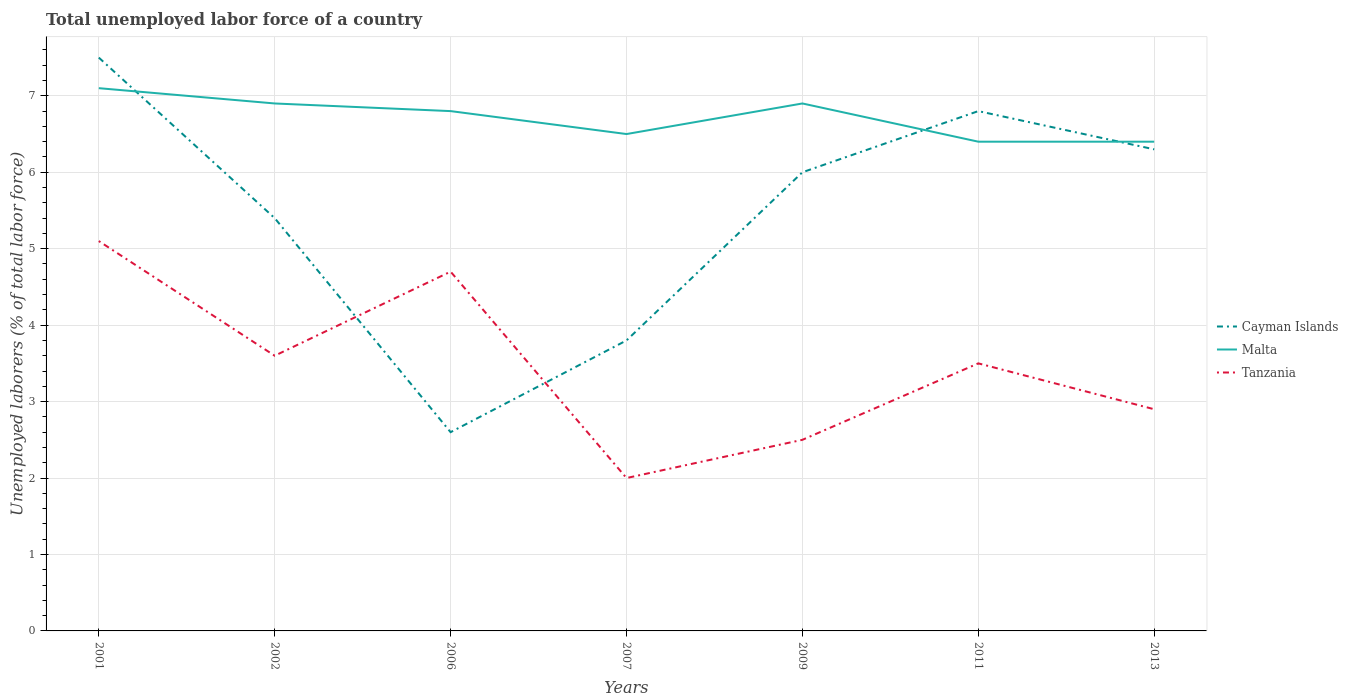Is the number of lines equal to the number of legend labels?
Provide a succinct answer. Yes. Across all years, what is the maximum total unemployed labor force in Malta?
Your response must be concise. 6.4. In which year was the total unemployed labor force in Cayman Islands maximum?
Offer a terse response. 2006. What is the total total unemployed labor force in Malta in the graph?
Your response must be concise. -0.4. What is the difference between the highest and the second highest total unemployed labor force in Tanzania?
Your answer should be compact. 3.1. What is the difference between the highest and the lowest total unemployed labor force in Tanzania?
Keep it short and to the point. 4. Is the total unemployed labor force in Malta strictly greater than the total unemployed labor force in Tanzania over the years?
Make the answer very short. No. What is the difference between two consecutive major ticks on the Y-axis?
Give a very brief answer. 1. Are the values on the major ticks of Y-axis written in scientific E-notation?
Give a very brief answer. No. Does the graph contain any zero values?
Your answer should be very brief. No. Does the graph contain grids?
Make the answer very short. Yes. Where does the legend appear in the graph?
Offer a very short reply. Center right. How are the legend labels stacked?
Your response must be concise. Vertical. What is the title of the graph?
Your response must be concise. Total unemployed labor force of a country. Does "Cabo Verde" appear as one of the legend labels in the graph?
Your answer should be very brief. No. What is the label or title of the Y-axis?
Your response must be concise. Unemployed laborers (% of total labor force). What is the Unemployed laborers (% of total labor force) in Malta in 2001?
Your answer should be very brief. 7.1. What is the Unemployed laborers (% of total labor force) in Tanzania in 2001?
Provide a succinct answer. 5.1. What is the Unemployed laborers (% of total labor force) of Cayman Islands in 2002?
Keep it short and to the point. 5.4. What is the Unemployed laborers (% of total labor force) of Malta in 2002?
Your answer should be very brief. 6.9. What is the Unemployed laborers (% of total labor force) in Tanzania in 2002?
Give a very brief answer. 3.6. What is the Unemployed laborers (% of total labor force) of Cayman Islands in 2006?
Provide a succinct answer. 2.6. What is the Unemployed laborers (% of total labor force) in Malta in 2006?
Offer a terse response. 6.8. What is the Unemployed laborers (% of total labor force) of Tanzania in 2006?
Offer a very short reply. 4.7. What is the Unemployed laborers (% of total labor force) in Cayman Islands in 2007?
Make the answer very short. 3.8. What is the Unemployed laborers (% of total labor force) in Tanzania in 2007?
Your answer should be very brief. 2. What is the Unemployed laborers (% of total labor force) in Malta in 2009?
Give a very brief answer. 6.9. What is the Unemployed laborers (% of total labor force) of Tanzania in 2009?
Keep it short and to the point. 2.5. What is the Unemployed laborers (% of total labor force) in Cayman Islands in 2011?
Your answer should be very brief. 6.8. What is the Unemployed laborers (% of total labor force) in Malta in 2011?
Offer a very short reply. 6.4. What is the Unemployed laborers (% of total labor force) of Tanzania in 2011?
Offer a terse response. 3.5. What is the Unemployed laborers (% of total labor force) of Cayman Islands in 2013?
Your answer should be compact. 6.3. What is the Unemployed laborers (% of total labor force) of Malta in 2013?
Your response must be concise. 6.4. What is the Unemployed laborers (% of total labor force) of Tanzania in 2013?
Keep it short and to the point. 2.9. Across all years, what is the maximum Unemployed laborers (% of total labor force) of Cayman Islands?
Your answer should be compact. 7.5. Across all years, what is the maximum Unemployed laborers (% of total labor force) of Malta?
Ensure brevity in your answer.  7.1. Across all years, what is the maximum Unemployed laborers (% of total labor force) in Tanzania?
Offer a terse response. 5.1. Across all years, what is the minimum Unemployed laborers (% of total labor force) in Cayman Islands?
Your response must be concise. 2.6. Across all years, what is the minimum Unemployed laborers (% of total labor force) in Malta?
Make the answer very short. 6.4. What is the total Unemployed laborers (% of total labor force) of Cayman Islands in the graph?
Ensure brevity in your answer.  38.4. What is the total Unemployed laborers (% of total labor force) in Malta in the graph?
Provide a succinct answer. 47. What is the total Unemployed laborers (% of total labor force) in Tanzania in the graph?
Your answer should be compact. 24.3. What is the difference between the Unemployed laborers (% of total labor force) in Malta in 2001 and that in 2002?
Offer a very short reply. 0.2. What is the difference between the Unemployed laborers (% of total labor force) of Cayman Islands in 2001 and that in 2006?
Ensure brevity in your answer.  4.9. What is the difference between the Unemployed laborers (% of total labor force) of Malta in 2001 and that in 2006?
Make the answer very short. 0.3. What is the difference between the Unemployed laborers (% of total labor force) in Tanzania in 2001 and that in 2006?
Ensure brevity in your answer.  0.4. What is the difference between the Unemployed laborers (% of total labor force) of Cayman Islands in 2001 and that in 2007?
Ensure brevity in your answer.  3.7. What is the difference between the Unemployed laborers (% of total labor force) in Cayman Islands in 2001 and that in 2013?
Keep it short and to the point. 1.2. What is the difference between the Unemployed laborers (% of total labor force) in Cayman Islands in 2002 and that in 2007?
Provide a short and direct response. 1.6. What is the difference between the Unemployed laborers (% of total labor force) of Malta in 2002 and that in 2007?
Ensure brevity in your answer.  0.4. What is the difference between the Unemployed laborers (% of total labor force) in Malta in 2002 and that in 2009?
Offer a terse response. 0. What is the difference between the Unemployed laborers (% of total labor force) of Cayman Islands in 2002 and that in 2013?
Offer a very short reply. -0.9. What is the difference between the Unemployed laborers (% of total labor force) of Malta in 2002 and that in 2013?
Your answer should be very brief. 0.5. What is the difference between the Unemployed laborers (% of total labor force) in Tanzania in 2002 and that in 2013?
Make the answer very short. 0.7. What is the difference between the Unemployed laborers (% of total labor force) in Cayman Islands in 2006 and that in 2007?
Provide a succinct answer. -1.2. What is the difference between the Unemployed laborers (% of total labor force) of Malta in 2006 and that in 2007?
Your response must be concise. 0.3. What is the difference between the Unemployed laborers (% of total labor force) in Cayman Islands in 2006 and that in 2009?
Provide a succinct answer. -3.4. What is the difference between the Unemployed laborers (% of total labor force) of Tanzania in 2006 and that in 2009?
Ensure brevity in your answer.  2.2. What is the difference between the Unemployed laborers (% of total labor force) in Cayman Islands in 2006 and that in 2011?
Ensure brevity in your answer.  -4.2. What is the difference between the Unemployed laborers (% of total labor force) in Malta in 2006 and that in 2011?
Provide a short and direct response. 0.4. What is the difference between the Unemployed laborers (% of total labor force) of Tanzania in 2006 and that in 2011?
Offer a very short reply. 1.2. What is the difference between the Unemployed laborers (% of total labor force) in Cayman Islands in 2006 and that in 2013?
Ensure brevity in your answer.  -3.7. What is the difference between the Unemployed laborers (% of total labor force) of Malta in 2007 and that in 2009?
Make the answer very short. -0.4. What is the difference between the Unemployed laborers (% of total labor force) of Tanzania in 2007 and that in 2009?
Your answer should be compact. -0.5. What is the difference between the Unemployed laborers (% of total labor force) of Cayman Islands in 2007 and that in 2011?
Ensure brevity in your answer.  -3. What is the difference between the Unemployed laborers (% of total labor force) of Malta in 2007 and that in 2011?
Offer a terse response. 0.1. What is the difference between the Unemployed laborers (% of total labor force) in Cayman Islands in 2007 and that in 2013?
Provide a short and direct response. -2.5. What is the difference between the Unemployed laborers (% of total labor force) of Malta in 2007 and that in 2013?
Provide a succinct answer. 0.1. What is the difference between the Unemployed laborers (% of total labor force) of Cayman Islands in 2009 and that in 2011?
Offer a very short reply. -0.8. What is the difference between the Unemployed laborers (% of total labor force) of Malta in 2009 and that in 2011?
Provide a succinct answer. 0.5. What is the difference between the Unemployed laborers (% of total labor force) of Tanzania in 2009 and that in 2011?
Your answer should be compact. -1. What is the difference between the Unemployed laborers (% of total labor force) of Malta in 2009 and that in 2013?
Your answer should be compact. 0.5. What is the difference between the Unemployed laborers (% of total labor force) of Tanzania in 2009 and that in 2013?
Your response must be concise. -0.4. What is the difference between the Unemployed laborers (% of total labor force) in Cayman Islands in 2011 and that in 2013?
Your answer should be very brief. 0.5. What is the difference between the Unemployed laborers (% of total labor force) in Tanzania in 2011 and that in 2013?
Offer a terse response. 0.6. What is the difference between the Unemployed laborers (% of total labor force) of Cayman Islands in 2001 and the Unemployed laborers (% of total labor force) of Malta in 2002?
Your answer should be compact. 0.6. What is the difference between the Unemployed laborers (% of total labor force) in Cayman Islands in 2001 and the Unemployed laborers (% of total labor force) in Tanzania in 2002?
Keep it short and to the point. 3.9. What is the difference between the Unemployed laborers (% of total labor force) in Malta in 2001 and the Unemployed laborers (% of total labor force) in Tanzania in 2002?
Your answer should be very brief. 3.5. What is the difference between the Unemployed laborers (% of total labor force) of Cayman Islands in 2001 and the Unemployed laborers (% of total labor force) of Malta in 2006?
Provide a short and direct response. 0.7. What is the difference between the Unemployed laborers (% of total labor force) in Cayman Islands in 2001 and the Unemployed laborers (% of total labor force) in Tanzania in 2006?
Your response must be concise. 2.8. What is the difference between the Unemployed laborers (% of total labor force) in Cayman Islands in 2001 and the Unemployed laborers (% of total labor force) in Malta in 2009?
Make the answer very short. 0.6. What is the difference between the Unemployed laborers (% of total labor force) of Cayman Islands in 2001 and the Unemployed laborers (% of total labor force) of Tanzania in 2009?
Your answer should be very brief. 5. What is the difference between the Unemployed laborers (% of total labor force) of Cayman Islands in 2001 and the Unemployed laborers (% of total labor force) of Malta in 2011?
Provide a succinct answer. 1.1. What is the difference between the Unemployed laborers (% of total labor force) in Cayman Islands in 2001 and the Unemployed laborers (% of total labor force) in Tanzania in 2011?
Make the answer very short. 4. What is the difference between the Unemployed laborers (% of total labor force) in Cayman Islands in 2001 and the Unemployed laborers (% of total labor force) in Tanzania in 2013?
Offer a terse response. 4.6. What is the difference between the Unemployed laborers (% of total labor force) in Malta in 2001 and the Unemployed laborers (% of total labor force) in Tanzania in 2013?
Your response must be concise. 4.2. What is the difference between the Unemployed laborers (% of total labor force) of Cayman Islands in 2002 and the Unemployed laborers (% of total labor force) of Tanzania in 2006?
Your answer should be very brief. 0.7. What is the difference between the Unemployed laborers (% of total labor force) of Malta in 2002 and the Unemployed laborers (% of total labor force) of Tanzania in 2006?
Offer a very short reply. 2.2. What is the difference between the Unemployed laborers (% of total labor force) in Cayman Islands in 2002 and the Unemployed laborers (% of total labor force) in Malta in 2007?
Ensure brevity in your answer.  -1.1. What is the difference between the Unemployed laborers (% of total labor force) of Cayman Islands in 2002 and the Unemployed laborers (% of total labor force) of Tanzania in 2007?
Offer a very short reply. 3.4. What is the difference between the Unemployed laborers (% of total labor force) of Malta in 2002 and the Unemployed laborers (% of total labor force) of Tanzania in 2007?
Your answer should be very brief. 4.9. What is the difference between the Unemployed laborers (% of total labor force) of Cayman Islands in 2002 and the Unemployed laborers (% of total labor force) of Tanzania in 2009?
Ensure brevity in your answer.  2.9. What is the difference between the Unemployed laborers (% of total labor force) in Cayman Islands in 2002 and the Unemployed laborers (% of total labor force) in Malta in 2011?
Your answer should be compact. -1. What is the difference between the Unemployed laborers (% of total labor force) of Cayman Islands in 2002 and the Unemployed laborers (% of total labor force) of Tanzania in 2011?
Provide a succinct answer. 1.9. What is the difference between the Unemployed laborers (% of total labor force) of Malta in 2002 and the Unemployed laborers (% of total labor force) of Tanzania in 2011?
Give a very brief answer. 3.4. What is the difference between the Unemployed laborers (% of total labor force) in Cayman Islands in 2002 and the Unemployed laborers (% of total labor force) in Tanzania in 2013?
Provide a succinct answer. 2.5. What is the difference between the Unemployed laborers (% of total labor force) of Cayman Islands in 2006 and the Unemployed laborers (% of total labor force) of Tanzania in 2007?
Keep it short and to the point. 0.6. What is the difference between the Unemployed laborers (% of total labor force) in Malta in 2006 and the Unemployed laborers (% of total labor force) in Tanzania in 2007?
Your response must be concise. 4.8. What is the difference between the Unemployed laborers (% of total labor force) of Cayman Islands in 2006 and the Unemployed laborers (% of total labor force) of Malta in 2009?
Make the answer very short. -4.3. What is the difference between the Unemployed laborers (% of total labor force) of Cayman Islands in 2006 and the Unemployed laborers (% of total labor force) of Tanzania in 2009?
Keep it short and to the point. 0.1. What is the difference between the Unemployed laborers (% of total labor force) in Cayman Islands in 2006 and the Unemployed laborers (% of total labor force) in Malta in 2011?
Make the answer very short. -3.8. What is the difference between the Unemployed laborers (% of total labor force) in Cayman Islands in 2006 and the Unemployed laborers (% of total labor force) in Tanzania in 2011?
Keep it short and to the point. -0.9. What is the difference between the Unemployed laborers (% of total labor force) in Malta in 2006 and the Unemployed laborers (% of total labor force) in Tanzania in 2011?
Make the answer very short. 3.3. What is the difference between the Unemployed laborers (% of total labor force) of Cayman Islands in 2006 and the Unemployed laborers (% of total labor force) of Malta in 2013?
Ensure brevity in your answer.  -3.8. What is the difference between the Unemployed laborers (% of total labor force) in Malta in 2006 and the Unemployed laborers (% of total labor force) in Tanzania in 2013?
Give a very brief answer. 3.9. What is the difference between the Unemployed laborers (% of total labor force) of Cayman Islands in 2007 and the Unemployed laborers (% of total labor force) of Malta in 2009?
Your response must be concise. -3.1. What is the difference between the Unemployed laborers (% of total labor force) in Malta in 2007 and the Unemployed laborers (% of total labor force) in Tanzania in 2009?
Make the answer very short. 4. What is the difference between the Unemployed laborers (% of total labor force) of Cayman Islands in 2007 and the Unemployed laborers (% of total labor force) of Malta in 2011?
Make the answer very short. -2.6. What is the difference between the Unemployed laborers (% of total labor force) in Cayman Islands in 2007 and the Unemployed laborers (% of total labor force) in Tanzania in 2013?
Provide a short and direct response. 0.9. What is the difference between the Unemployed laborers (% of total labor force) in Cayman Islands in 2009 and the Unemployed laborers (% of total labor force) in Malta in 2011?
Make the answer very short. -0.4. What is the difference between the Unemployed laborers (% of total labor force) of Cayman Islands in 2009 and the Unemployed laborers (% of total labor force) of Tanzania in 2013?
Provide a succinct answer. 3.1. What is the difference between the Unemployed laborers (% of total labor force) of Malta in 2009 and the Unemployed laborers (% of total labor force) of Tanzania in 2013?
Give a very brief answer. 4. What is the difference between the Unemployed laborers (% of total labor force) of Cayman Islands in 2011 and the Unemployed laborers (% of total labor force) of Malta in 2013?
Provide a succinct answer. 0.4. What is the difference between the Unemployed laborers (% of total labor force) of Malta in 2011 and the Unemployed laborers (% of total labor force) of Tanzania in 2013?
Provide a succinct answer. 3.5. What is the average Unemployed laborers (% of total labor force) of Cayman Islands per year?
Keep it short and to the point. 5.49. What is the average Unemployed laborers (% of total labor force) in Malta per year?
Ensure brevity in your answer.  6.71. What is the average Unemployed laborers (% of total labor force) in Tanzania per year?
Your answer should be very brief. 3.47. In the year 2001, what is the difference between the Unemployed laborers (% of total labor force) of Cayman Islands and Unemployed laborers (% of total labor force) of Malta?
Your answer should be very brief. 0.4. In the year 2001, what is the difference between the Unemployed laborers (% of total labor force) of Cayman Islands and Unemployed laborers (% of total labor force) of Tanzania?
Offer a terse response. 2.4. In the year 2001, what is the difference between the Unemployed laborers (% of total labor force) in Malta and Unemployed laborers (% of total labor force) in Tanzania?
Give a very brief answer. 2. In the year 2002, what is the difference between the Unemployed laborers (% of total labor force) of Cayman Islands and Unemployed laborers (% of total labor force) of Malta?
Ensure brevity in your answer.  -1.5. In the year 2002, what is the difference between the Unemployed laborers (% of total labor force) of Cayman Islands and Unemployed laborers (% of total labor force) of Tanzania?
Provide a succinct answer. 1.8. In the year 2002, what is the difference between the Unemployed laborers (% of total labor force) in Malta and Unemployed laborers (% of total labor force) in Tanzania?
Offer a terse response. 3.3. In the year 2006, what is the difference between the Unemployed laborers (% of total labor force) of Cayman Islands and Unemployed laborers (% of total labor force) of Tanzania?
Provide a succinct answer. -2.1. In the year 2006, what is the difference between the Unemployed laborers (% of total labor force) of Malta and Unemployed laborers (% of total labor force) of Tanzania?
Your response must be concise. 2.1. In the year 2007, what is the difference between the Unemployed laborers (% of total labor force) of Malta and Unemployed laborers (% of total labor force) of Tanzania?
Provide a short and direct response. 4.5. In the year 2009, what is the difference between the Unemployed laborers (% of total labor force) in Cayman Islands and Unemployed laborers (% of total labor force) in Malta?
Provide a succinct answer. -0.9. In the year 2009, what is the difference between the Unemployed laborers (% of total labor force) in Cayman Islands and Unemployed laborers (% of total labor force) in Tanzania?
Your answer should be very brief. 3.5. In the year 2009, what is the difference between the Unemployed laborers (% of total labor force) in Malta and Unemployed laborers (% of total labor force) in Tanzania?
Give a very brief answer. 4.4. In the year 2011, what is the difference between the Unemployed laborers (% of total labor force) in Cayman Islands and Unemployed laborers (% of total labor force) in Malta?
Offer a very short reply. 0.4. In the year 2011, what is the difference between the Unemployed laborers (% of total labor force) of Cayman Islands and Unemployed laborers (% of total labor force) of Tanzania?
Provide a succinct answer. 3.3. In the year 2011, what is the difference between the Unemployed laborers (% of total labor force) of Malta and Unemployed laborers (% of total labor force) of Tanzania?
Make the answer very short. 2.9. What is the ratio of the Unemployed laborers (% of total labor force) in Cayman Islands in 2001 to that in 2002?
Offer a very short reply. 1.39. What is the ratio of the Unemployed laborers (% of total labor force) of Malta in 2001 to that in 2002?
Keep it short and to the point. 1.03. What is the ratio of the Unemployed laborers (% of total labor force) of Tanzania in 2001 to that in 2002?
Provide a succinct answer. 1.42. What is the ratio of the Unemployed laborers (% of total labor force) in Cayman Islands in 2001 to that in 2006?
Make the answer very short. 2.88. What is the ratio of the Unemployed laborers (% of total labor force) of Malta in 2001 to that in 2006?
Make the answer very short. 1.04. What is the ratio of the Unemployed laborers (% of total labor force) in Tanzania in 2001 to that in 2006?
Offer a terse response. 1.09. What is the ratio of the Unemployed laborers (% of total labor force) in Cayman Islands in 2001 to that in 2007?
Keep it short and to the point. 1.97. What is the ratio of the Unemployed laborers (% of total labor force) of Malta in 2001 to that in 2007?
Your answer should be very brief. 1.09. What is the ratio of the Unemployed laborers (% of total labor force) of Tanzania in 2001 to that in 2007?
Provide a short and direct response. 2.55. What is the ratio of the Unemployed laborers (% of total labor force) in Tanzania in 2001 to that in 2009?
Give a very brief answer. 2.04. What is the ratio of the Unemployed laborers (% of total labor force) in Cayman Islands in 2001 to that in 2011?
Keep it short and to the point. 1.1. What is the ratio of the Unemployed laborers (% of total labor force) of Malta in 2001 to that in 2011?
Ensure brevity in your answer.  1.11. What is the ratio of the Unemployed laborers (% of total labor force) of Tanzania in 2001 to that in 2011?
Provide a short and direct response. 1.46. What is the ratio of the Unemployed laborers (% of total labor force) in Cayman Islands in 2001 to that in 2013?
Offer a very short reply. 1.19. What is the ratio of the Unemployed laborers (% of total labor force) in Malta in 2001 to that in 2013?
Ensure brevity in your answer.  1.11. What is the ratio of the Unemployed laborers (% of total labor force) of Tanzania in 2001 to that in 2013?
Give a very brief answer. 1.76. What is the ratio of the Unemployed laborers (% of total labor force) of Cayman Islands in 2002 to that in 2006?
Give a very brief answer. 2.08. What is the ratio of the Unemployed laborers (% of total labor force) of Malta in 2002 to that in 2006?
Provide a short and direct response. 1.01. What is the ratio of the Unemployed laborers (% of total labor force) of Tanzania in 2002 to that in 2006?
Give a very brief answer. 0.77. What is the ratio of the Unemployed laborers (% of total labor force) in Cayman Islands in 2002 to that in 2007?
Your answer should be very brief. 1.42. What is the ratio of the Unemployed laborers (% of total labor force) of Malta in 2002 to that in 2007?
Your response must be concise. 1.06. What is the ratio of the Unemployed laborers (% of total labor force) in Tanzania in 2002 to that in 2009?
Ensure brevity in your answer.  1.44. What is the ratio of the Unemployed laborers (% of total labor force) of Cayman Islands in 2002 to that in 2011?
Ensure brevity in your answer.  0.79. What is the ratio of the Unemployed laborers (% of total labor force) in Malta in 2002 to that in 2011?
Your answer should be compact. 1.08. What is the ratio of the Unemployed laborers (% of total labor force) of Tanzania in 2002 to that in 2011?
Keep it short and to the point. 1.03. What is the ratio of the Unemployed laborers (% of total labor force) in Malta in 2002 to that in 2013?
Your answer should be very brief. 1.08. What is the ratio of the Unemployed laborers (% of total labor force) in Tanzania in 2002 to that in 2013?
Your answer should be compact. 1.24. What is the ratio of the Unemployed laborers (% of total labor force) in Cayman Islands in 2006 to that in 2007?
Keep it short and to the point. 0.68. What is the ratio of the Unemployed laborers (% of total labor force) of Malta in 2006 to that in 2007?
Your answer should be compact. 1.05. What is the ratio of the Unemployed laborers (% of total labor force) of Tanzania in 2006 to that in 2007?
Offer a terse response. 2.35. What is the ratio of the Unemployed laborers (% of total labor force) in Cayman Islands in 2006 to that in 2009?
Offer a terse response. 0.43. What is the ratio of the Unemployed laborers (% of total labor force) in Malta in 2006 to that in 2009?
Your answer should be very brief. 0.99. What is the ratio of the Unemployed laborers (% of total labor force) of Tanzania in 2006 to that in 2009?
Keep it short and to the point. 1.88. What is the ratio of the Unemployed laborers (% of total labor force) in Cayman Islands in 2006 to that in 2011?
Make the answer very short. 0.38. What is the ratio of the Unemployed laborers (% of total labor force) in Malta in 2006 to that in 2011?
Your response must be concise. 1.06. What is the ratio of the Unemployed laborers (% of total labor force) of Tanzania in 2006 to that in 2011?
Ensure brevity in your answer.  1.34. What is the ratio of the Unemployed laborers (% of total labor force) in Cayman Islands in 2006 to that in 2013?
Ensure brevity in your answer.  0.41. What is the ratio of the Unemployed laborers (% of total labor force) of Tanzania in 2006 to that in 2013?
Keep it short and to the point. 1.62. What is the ratio of the Unemployed laborers (% of total labor force) in Cayman Islands in 2007 to that in 2009?
Give a very brief answer. 0.63. What is the ratio of the Unemployed laborers (% of total labor force) of Malta in 2007 to that in 2009?
Your response must be concise. 0.94. What is the ratio of the Unemployed laborers (% of total labor force) in Tanzania in 2007 to that in 2009?
Provide a short and direct response. 0.8. What is the ratio of the Unemployed laborers (% of total labor force) in Cayman Islands in 2007 to that in 2011?
Give a very brief answer. 0.56. What is the ratio of the Unemployed laborers (% of total labor force) of Malta in 2007 to that in 2011?
Provide a succinct answer. 1.02. What is the ratio of the Unemployed laborers (% of total labor force) of Cayman Islands in 2007 to that in 2013?
Your response must be concise. 0.6. What is the ratio of the Unemployed laborers (% of total labor force) of Malta in 2007 to that in 2013?
Provide a short and direct response. 1.02. What is the ratio of the Unemployed laborers (% of total labor force) in Tanzania in 2007 to that in 2013?
Your answer should be compact. 0.69. What is the ratio of the Unemployed laborers (% of total labor force) in Cayman Islands in 2009 to that in 2011?
Give a very brief answer. 0.88. What is the ratio of the Unemployed laborers (% of total labor force) in Malta in 2009 to that in 2011?
Give a very brief answer. 1.08. What is the ratio of the Unemployed laborers (% of total labor force) in Tanzania in 2009 to that in 2011?
Give a very brief answer. 0.71. What is the ratio of the Unemployed laborers (% of total labor force) in Cayman Islands in 2009 to that in 2013?
Ensure brevity in your answer.  0.95. What is the ratio of the Unemployed laborers (% of total labor force) in Malta in 2009 to that in 2013?
Your answer should be very brief. 1.08. What is the ratio of the Unemployed laborers (% of total labor force) of Tanzania in 2009 to that in 2013?
Provide a short and direct response. 0.86. What is the ratio of the Unemployed laborers (% of total labor force) in Cayman Islands in 2011 to that in 2013?
Your answer should be very brief. 1.08. What is the ratio of the Unemployed laborers (% of total labor force) in Malta in 2011 to that in 2013?
Keep it short and to the point. 1. What is the ratio of the Unemployed laborers (% of total labor force) in Tanzania in 2011 to that in 2013?
Provide a succinct answer. 1.21. What is the difference between the highest and the second highest Unemployed laborers (% of total labor force) in Malta?
Your answer should be very brief. 0.2. What is the difference between the highest and the lowest Unemployed laborers (% of total labor force) of Cayman Islands?
Provide a succinct answer. 4.9. What is the difference between the highest and the lowest Unemployed laborers (% of total labor force) in Tanzania?
Keep it short and to the point. 3.1. 